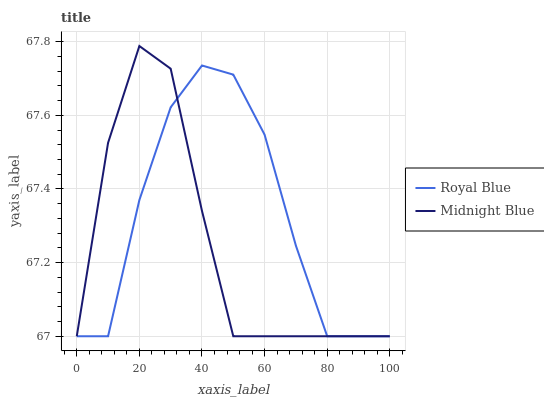Does Midnight Blue have the minimum area under the curve?
Answer yes or no. Yes. Does Royal Blue have the maximum area under the curve?
Answer yes or no. Yes. Does Midnight Blue have the maximum area under the curve?
Answer yes or no. No. Is Midnight Blue the smoothest?
Answer yes or no. Yes. Is Royal Blue the roughest?
Answer yes or no. Yes. Is Midnight Blue the roughest?
Answer yes or no. No. Does Royal Blue have the lowest value?
Answer yes or no. Yes. Does Midnight Blue have the highest value?
Answer yes or no. Yes. Does Midnight Blue intersect Royal Blue?
Answer yes or no. Yes. Is Midnight Blue less than Royal Blue?
Answer yes or no. No. Is Midnight Blue greater than Royal Blue?
Answer yes or no. No. 